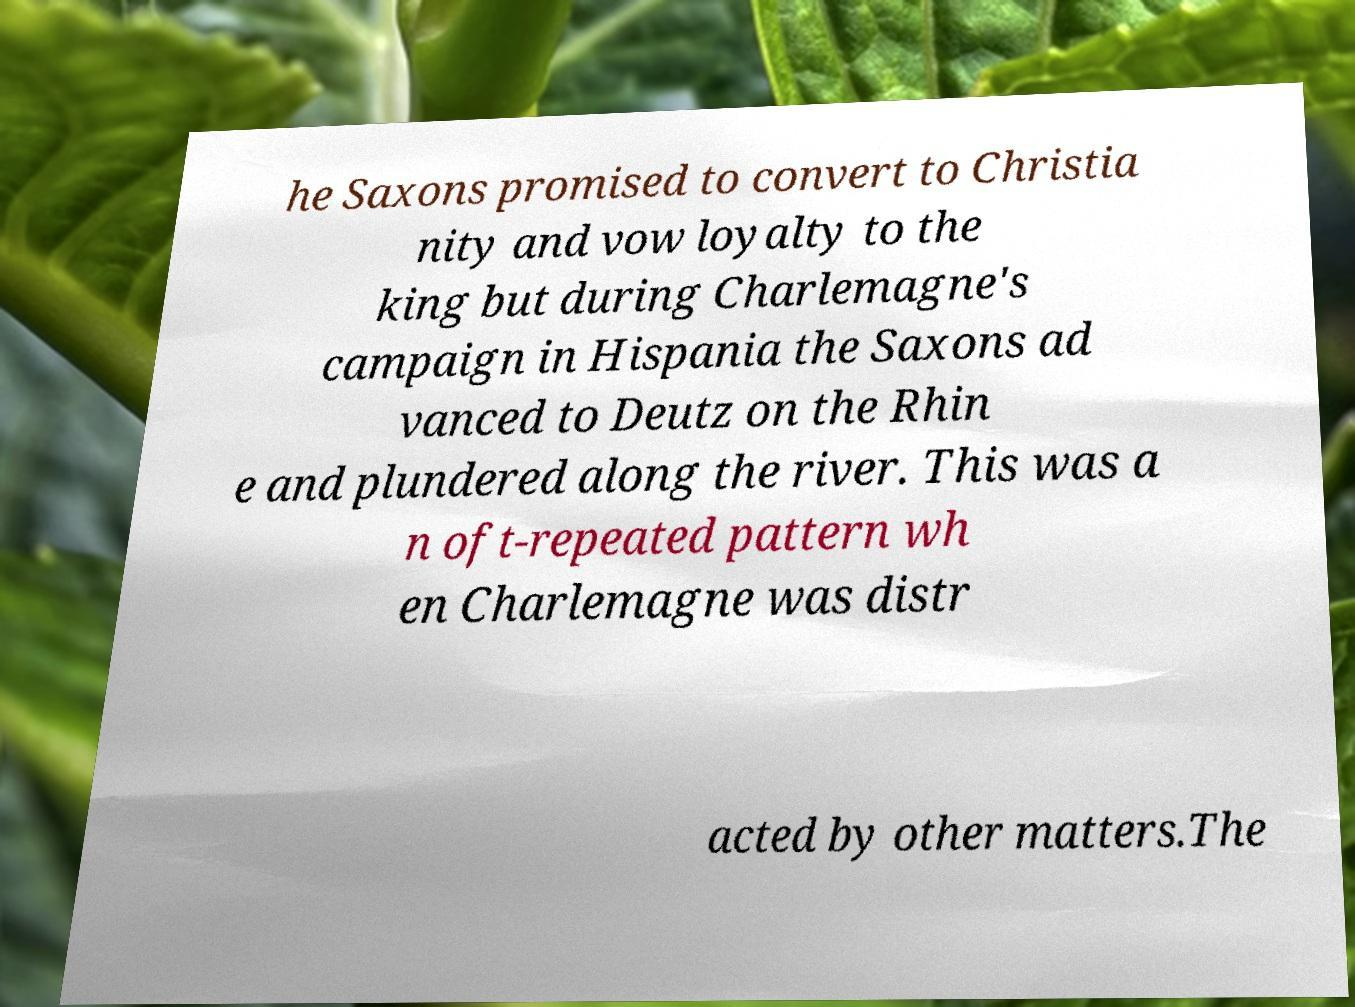There's text embedded in this image that I need extracted. Can you transcribe it verbatim? he Saxons promised to convert to Christia nity and vow loyalty to the king but during Charlemagne's campaign in Hispania the Saxons ad vanced to Deutz on the Rhin e and plundered along the river. This was a n oft-repeated pattern wh en Charlemagne was distr acted by other matters.The 